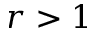<formula> <loc_0><loc_0><loc_500><loc_500>r > 1</formula> 